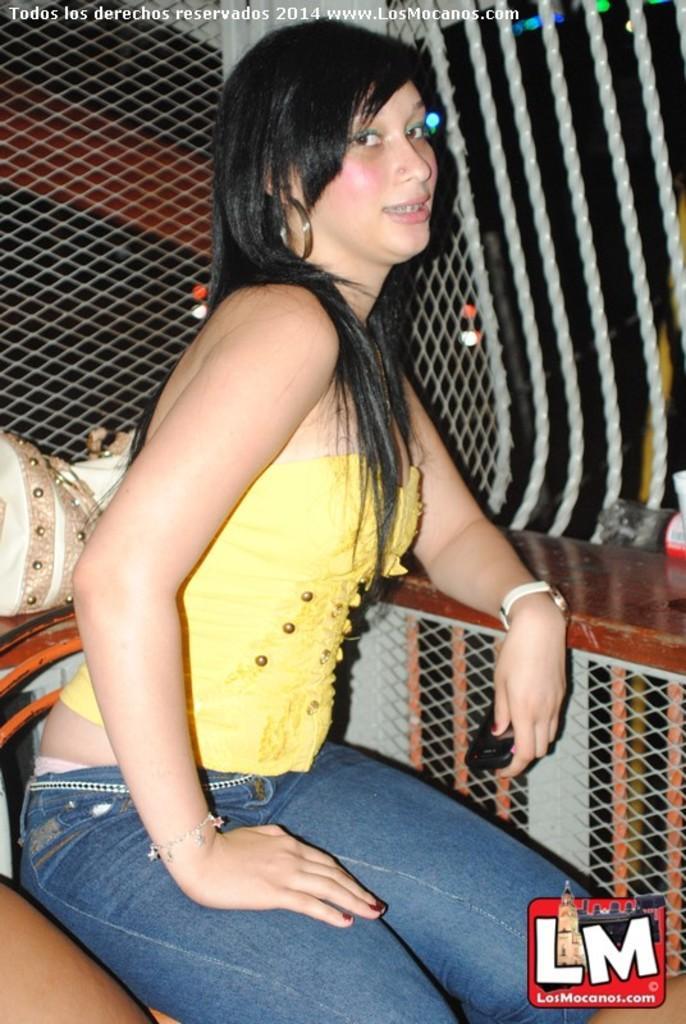Could you give a brief overview of what you see in this image? In this picture there is a woman with yellow top is sitting on the chair. At the back there is a fence and there is an object. At the top there are lights. At the bottom there is a watermark. 